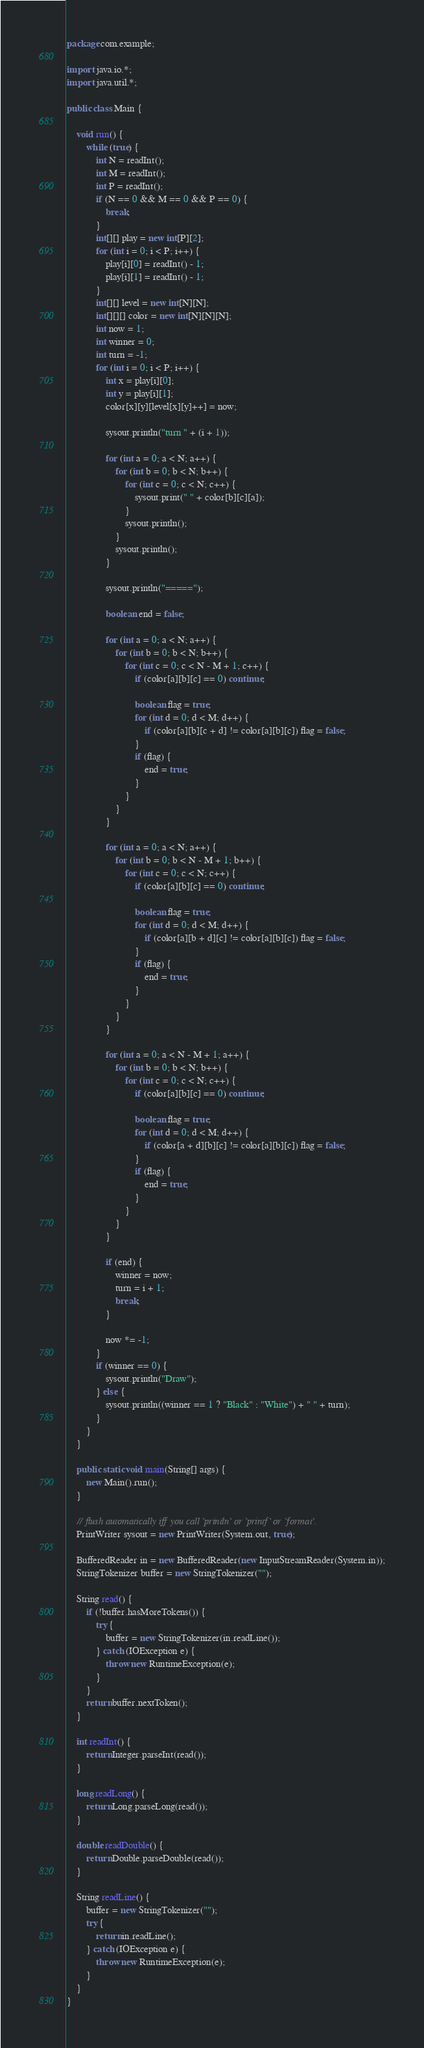<code> <loc_0><loc_0><loc_500><loc_500><_Java_>package com.example;

import java.io.*;
import java.util.*;

public class Main {

    void run() {
        while (true) {
            int N = readInt();
            int M = readInt();
            int P = readInt();
            if (N == 0 && M == 0 && P == 0) {
                break;
            }
            int[][] play = new int[P][2];
            for (int i = 0; i < P; i++) {
                play[i][0] = readInt() - 1;
                play[i][1] = readInt() - 1;
            }
            int[][] level = new int[N][N];
            int[][][] color = new int[N][N][N];
            int now = 1;
            int winner = 0;
            int turn = -1;
            for (int i = 0; i < P; i++) {
                int x = play[i][0];
                int y = play[i][1];
                color[x][y][level[x][y]++] = now;

                sysout.println("turn " + (i + 1));

                for (int a = 0; a < N; a++) {
                    for (int b = 0; b < N; b++) {
                        for (int c = 0; c < N; c++) {
                            sysout.print(" " + color[b][c][a]);
                        }
                        sysout.println();
                    }
                    sysout.println();
                }

                sysout.println("=====");

                boolean end = false;

                for (int a = 0; a < N; a++) {
                    for (int b = 0; b < N; b++) {
                        for (int c = 0; c < N - M + 1; c++) {
                            if (color[a][b][c] == 0) continue;

                            boolean flag = true;
                            for (int d = 0; d < M; d++) {
                                if (color[a][b][c + d] != color[a][b][c]) flag = false;
                            }
                            if (flag) {
                                end = true;
                            }
                        }
                    }
                }

                for (int a = 0; a < N; a++) {
                    for (int b = 0; b < N - M + 1; b++) {
                        for (int c = 0; c < N; c++) {
                            if (color[a][b][c] == 0) continue;

                            boolean flag = true;
                            for (int d = 0; d < M; d++) {
                                if (color[a][b + d][c] != color[a][b][c]) flag = false;
                            }
                            if (flag) {
                                end = true;
                            }
                        }
                    }
                }

                for (int a = 0; a < N - M + 1; a++) {
                    for (int b = 0; b < N; b++) {
                        for (int c = 0; c < N; c++) {
                            if (color[a][b][c] == 0) continue;

                            boolean flag = true;
                            for (int d = 0; d < M; d++) {
                                if (color[a + d][b][c] != color[a][b][c]) flag = false;
                            }
                            if (flag) {
                                end = true;
                            }
                        }
                    }
                }

                if (end) {
                    winner = now;
                    turn = i + 1;
                    break;
                }

                now *= -1;
            }
            if (winner == 0) {
                sysout.println("Draw");
            } else {
                sysout.println((winner == 1 ? "Black" : "White") + " " + turn);
            }
        }
    }

    public static void main(String[] args) {
        new Main().run();
    }

    // flush automatically iff you call `println` or `printf` or `format`.
    PrintWriter sysout = new PrintWriter(System.out, true);

    BufferedReader in = new BufferedReader(new InputStreamReader(System.in));
    StringTokenizer buffer = new StringTokenizer("");

    String read() {
        if (!buffer.hasMoreTokens()) {
            try {
                buffer = new StringTokenizer(in.readLine());
            } catch (IOException e) {
                throw new RuntimeException(e);
            }
        }
        return buffer.nextToken();
    }

    int readInt() {
        return Integer.parseInt(read());
    }

    long readLong() {
        return Long.parseLong(read());
    }

    double readDouble() {
        return Double.parseDouble(read());
    }

    String readLine() {
        buffer = new StringTokenizer("");
        try {
            return in.readLine();
        } catch (IOException e) {
            throw new RuntimeException(e);
        }
    }
}</code> 